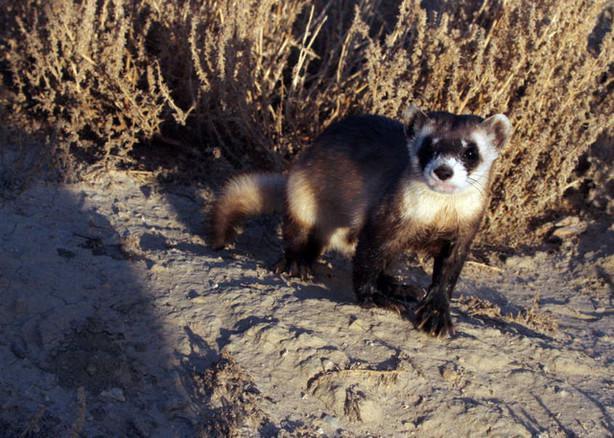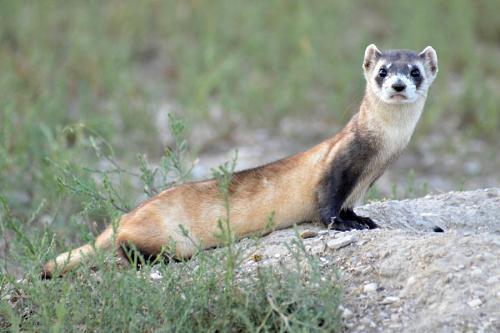The first image is the image on the left, the second image is the image on the right. For the images displayed, is the sentence "There are exactly two ferrets with heads facing directly at the camera." factually correct? Answer yes or no. Yes. The first image is the image on the left, the second image is the image on the right. Assess this claim about the two images: "Each image shows a single ferret, and each ferrret is standing on all fours and looking toward the camera.". Correct or not? Answer yes or no. Yes. 